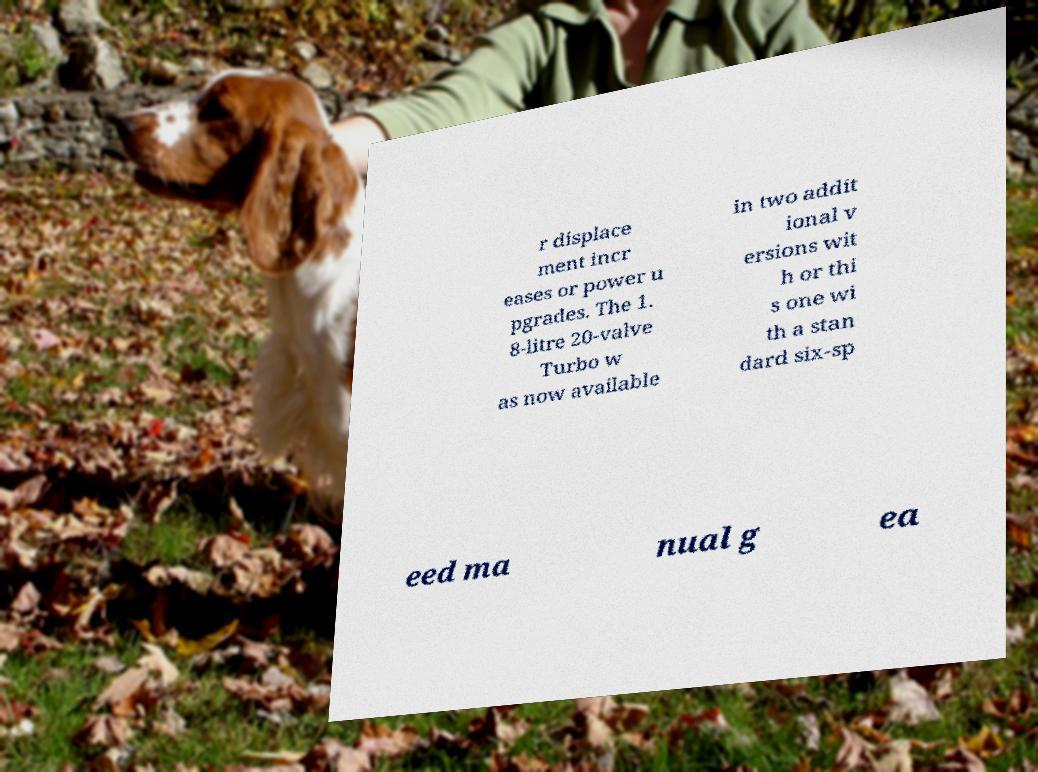Please identify and transcribe the text found in this image. r displace ment incr eases or power u pgrades. The 1. 8-litre 20-valve Turbo w as now available in two addit ional v ersions wit h or thi s one wi th a stan dard six-sp eed ma nual g ea 